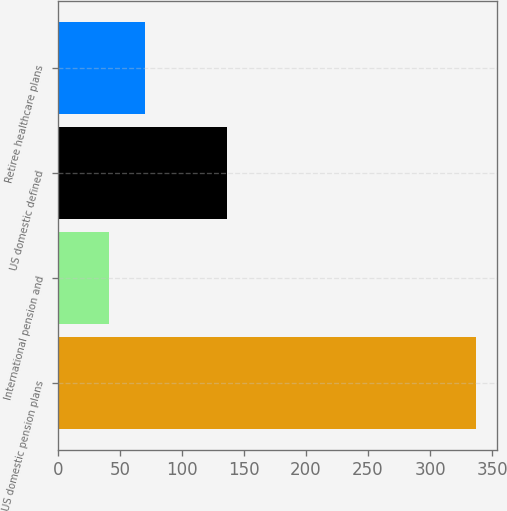<chart> <loc_0><loc_0><loc_500><loc_500><bar_chart><fcel>US domestic pension plans<fcel>International pension and<fcel>US domestic defined<fcel>Retiree healthcare plans<nl><fcel>337<fcel>41<fcel>136<fcel>70.6<nl></chart> 